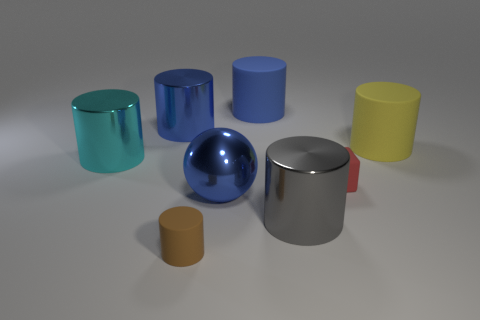What size is the blue thing that is on the left side of the small rubber cylinder?
Keep it short and to the point. Large. How many other large shiny balls are the same color as the large metal ball?
Give a very brief answer. 0. Is there a block that is in front of the tiny object on the right side of the gray metallic cylinder?
Keep it short and to the point. No. Is the color of the small object on the right side of the brown matte cylinder the same as the tiny object that is on the left side of the large gray thing?
Make the answer very short. No. There is a matte block that is the same size as the brown rubber object; what is its color?
Offer a terse response. Red. Are there the same number of blue matte objects that are left of the blue metal cylinder and big metallic spheres that are right of the big yellow cylinder?
Provide a succinct answer. Yes. There is a tiny cube that is on the right side of the large gray metal object in front of the big yellow thing; what is its material?
Offer a terse response. Rubber. How many objects are either rubber objects or gray rubber objects?
Provide a short and direct response. 4. There is a matte cylinder that is the same color as the large metal sphere; what is its size?
Ensure brevity in your answer.  Large. Are there fewer large blue matte cylinders than tiny cyan matte things?
Provide a short and direct response. No. 